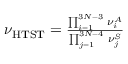<formula> <loc_0><loc_0><loc_500><loc_500>\begin{array} { r } { \nu _ { H T S T } = \frac { \prod _ { i = 1 } ^ { 3 N - 3 } \, \nu _ { i } ^ { A } } { \prod _ { j = 1 } ^ { 3 N - 4 } \, \nu _ { j } ^ { S } } } \end{array}</formula> 